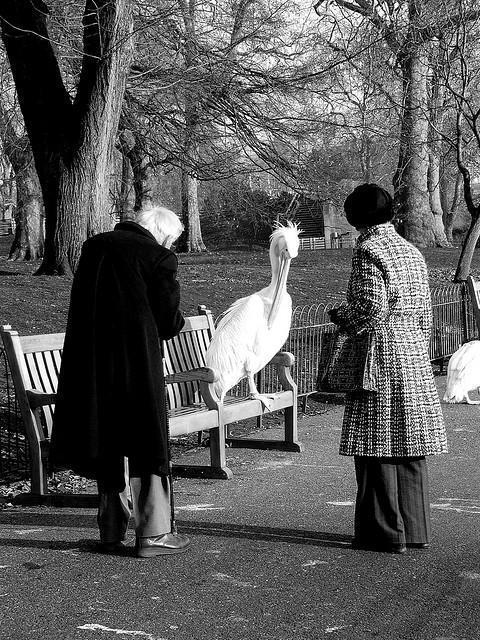How many people are there?
Give a very brief answer. 2. How many benches are there?
Give a very brief answer. 1. How many dogs are wearing a chain collar?
Give a very brief answer. 0. 